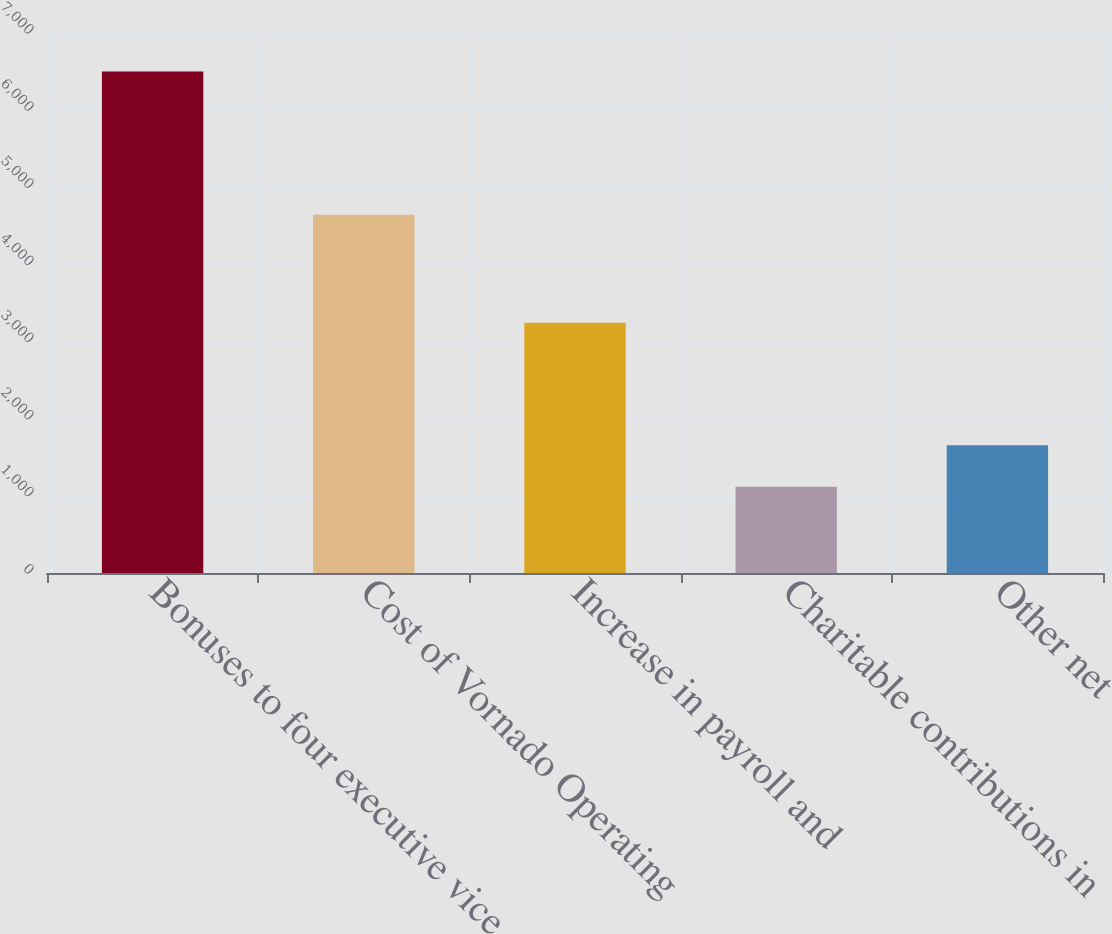Convert chart to OTSL. <chart><loc_0><loc_0><loc_500><loc_500><bar_chart><fcel>Bonuses to four executive vice<fcel>Cost of Vornado Operating<fcel>Increase in payroll and<fcel>Charitable contributions in<fcel>Other net<nl><fcel>6500<fcel>4643<fcel>3244<fcel>1119<fcel>1657.1<nl></chart> 